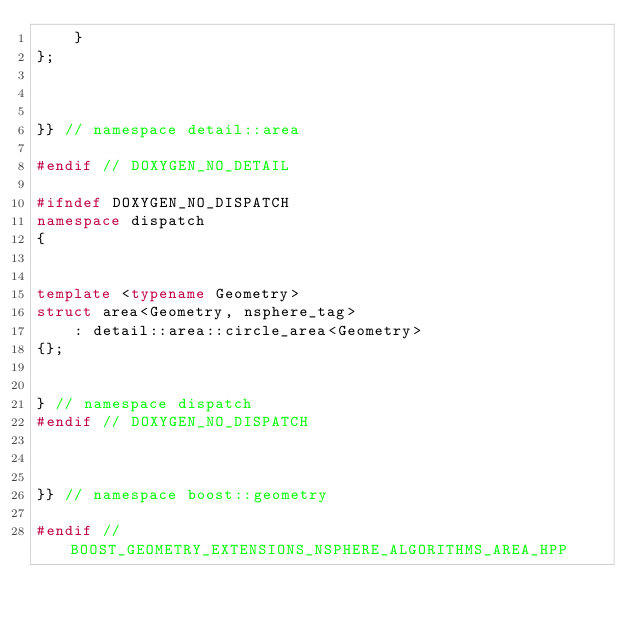Convert code to text. <code><loc_0><loc_0><loc_500><loc_500><_C++_>    }
};



}} // namespace detail::area

#endif // DOXYGEN_NO_DETAIL

#ifndef DOXYGEN_NO_DISPATCH
namespace dispatch
{


template <typename Geometry>
struct area<Geometry, nsphere_tag>
    : detail::area::circle_area<Geometry>
{};


} // namespace dispatch
#endif // DOXYGEN_NO_DISPATCH



}} // namespace boost::geometry

#endif // BOOST_GEOMETRY_EXTENSIONS_NSPHERE_ALGORITHMS_AREA_HPP
</code> 